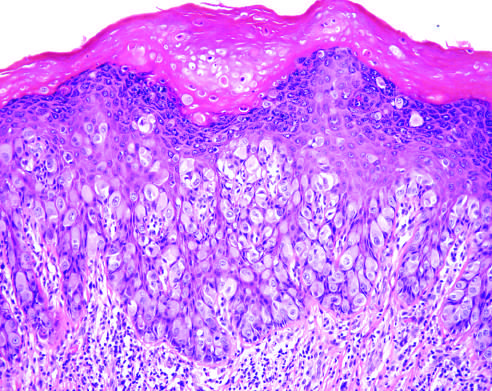what are large tumor cells with pale-pink cytoplasm seen infiltrating?
Answer the question using a single word or phrase. The epidermis 